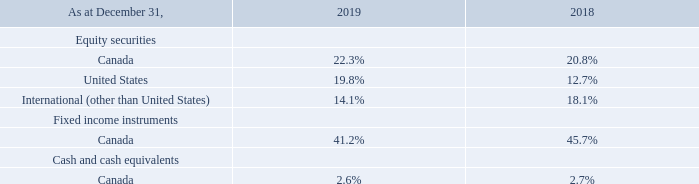30. EMPLOYEE BENEFIT PLANS (cont.)
The fair value of the plan assets were allocated as follows between the various types of investments:
Plan assets are valued at the measurement date of December 31 each year.
The investments are made in accordance with the Statement of Investment Policies and Procedures. The Statement of Investment Policies and Procedures is reviewed on an annual basis by the Management Level Pension Fund Investment Committee with approval of the policy being provided by the Audit Committee.
When are the plan assets valued each year? December 31 each year. How often is The Statement of Investment Policies and Procedures reviewed and who reviews it? Annual basis, the management level pension fund investment committee. What are the respective percentage of the plan assets fair value allocated to Canada equity securities in 2018 and 2019 respectively? 20.8%, 22.3%. What is the percentage change in plan asset fair value allocated in Canada equity securities between 2018 and 2019?
Answer scale should be: percent. 22.3% - 20.8% 
Answer: 1.5. What is the total percentage of plan asset fair value allocated to fixed income instruments in 2018 and 2019?
Answer scale should be: percent. 41.2% + 45.7% 
Answer: 86.9. What is the total percentage of plan asset fair value allocated to cash and cash equivalents in 2018 and 2019?
Answer scale should be: percent. 2.6% + 2.7% 
Answer: 5.3. 